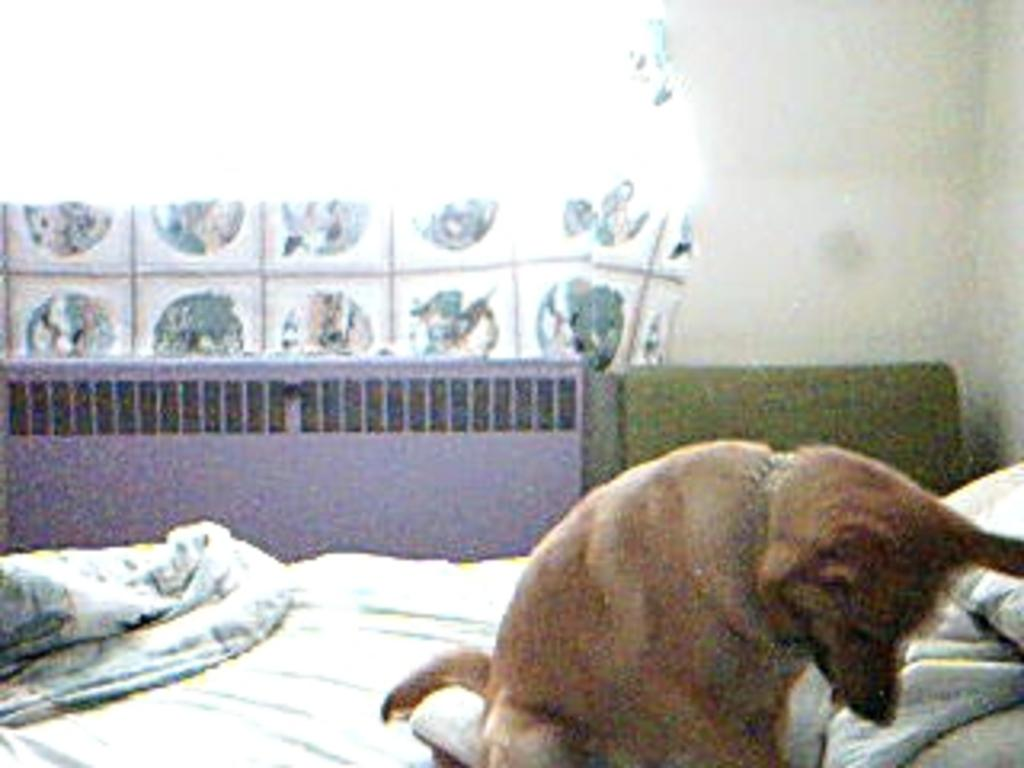What animal is sitting on the bed in the image? There is a dog sitting on the bed in the image. What type of fabric is present in the image? There is a blanket in the image. What type of window treatment is visible in the image? There is a curtain in the image. What type of structure is visible in the image? There is a wall in the image. What type of bedding is present on the bed? There are pillows on the bed. How many frogs are sitting on the bed with the dog in the image? There are no frogs present in the image; only a dog is sitting on the bed. What is the name of the dog's son in the image? There is no indication of a dog having a son in the image, nor is there any information about the dog's family. 